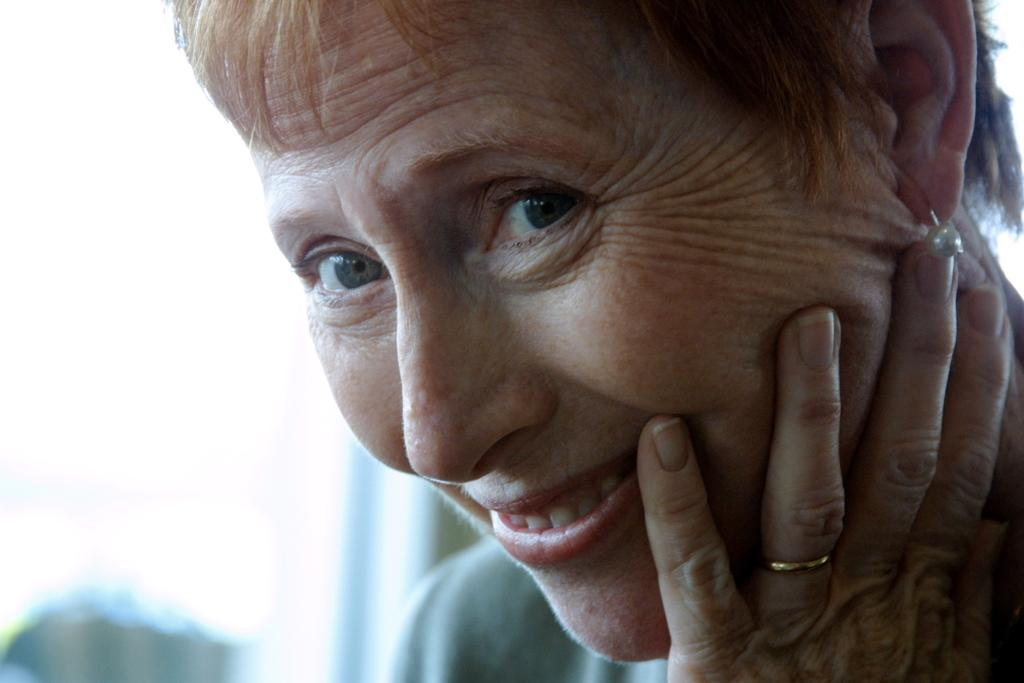Who is the main subject in the image? There is an old woman in the image. What type of jewelry is the old woman wearing? The old woman is wearing pearl earrings and a finger ring. How would you describe the old woman's hairstyle? The old woman has short hair. What color is the balloon held by the old woman in the image? There is no balloon present in the image. What type of cord is used to tie the old woman's hair in the image? The old woman's hair is short, so there is no need for a cord to tie it. 